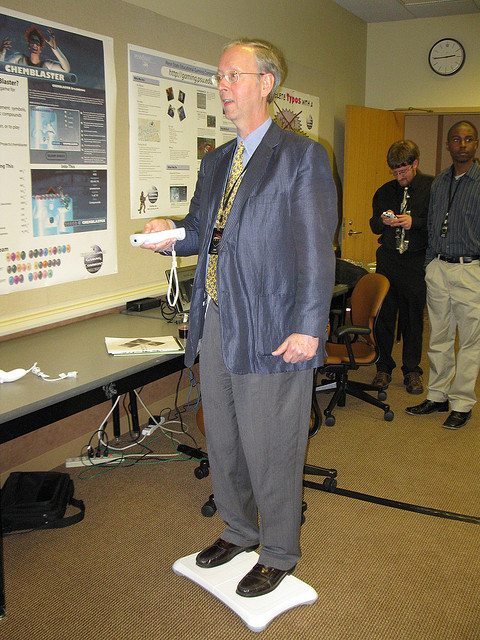Please transcribe the text information in this image. CHEMBLASTER Master types 